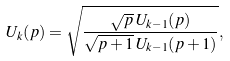<formula> <loc_0><loc_0><loc_500><loc_500>U _ { k } ( p ) = \sqrt { \frac { \sqrt { p } \, U _ { k - 1 } ( p ) } { \sqrt { p + 1 } \, U _ { k - 1 } ( p + 1 ) } } ,</formula> 